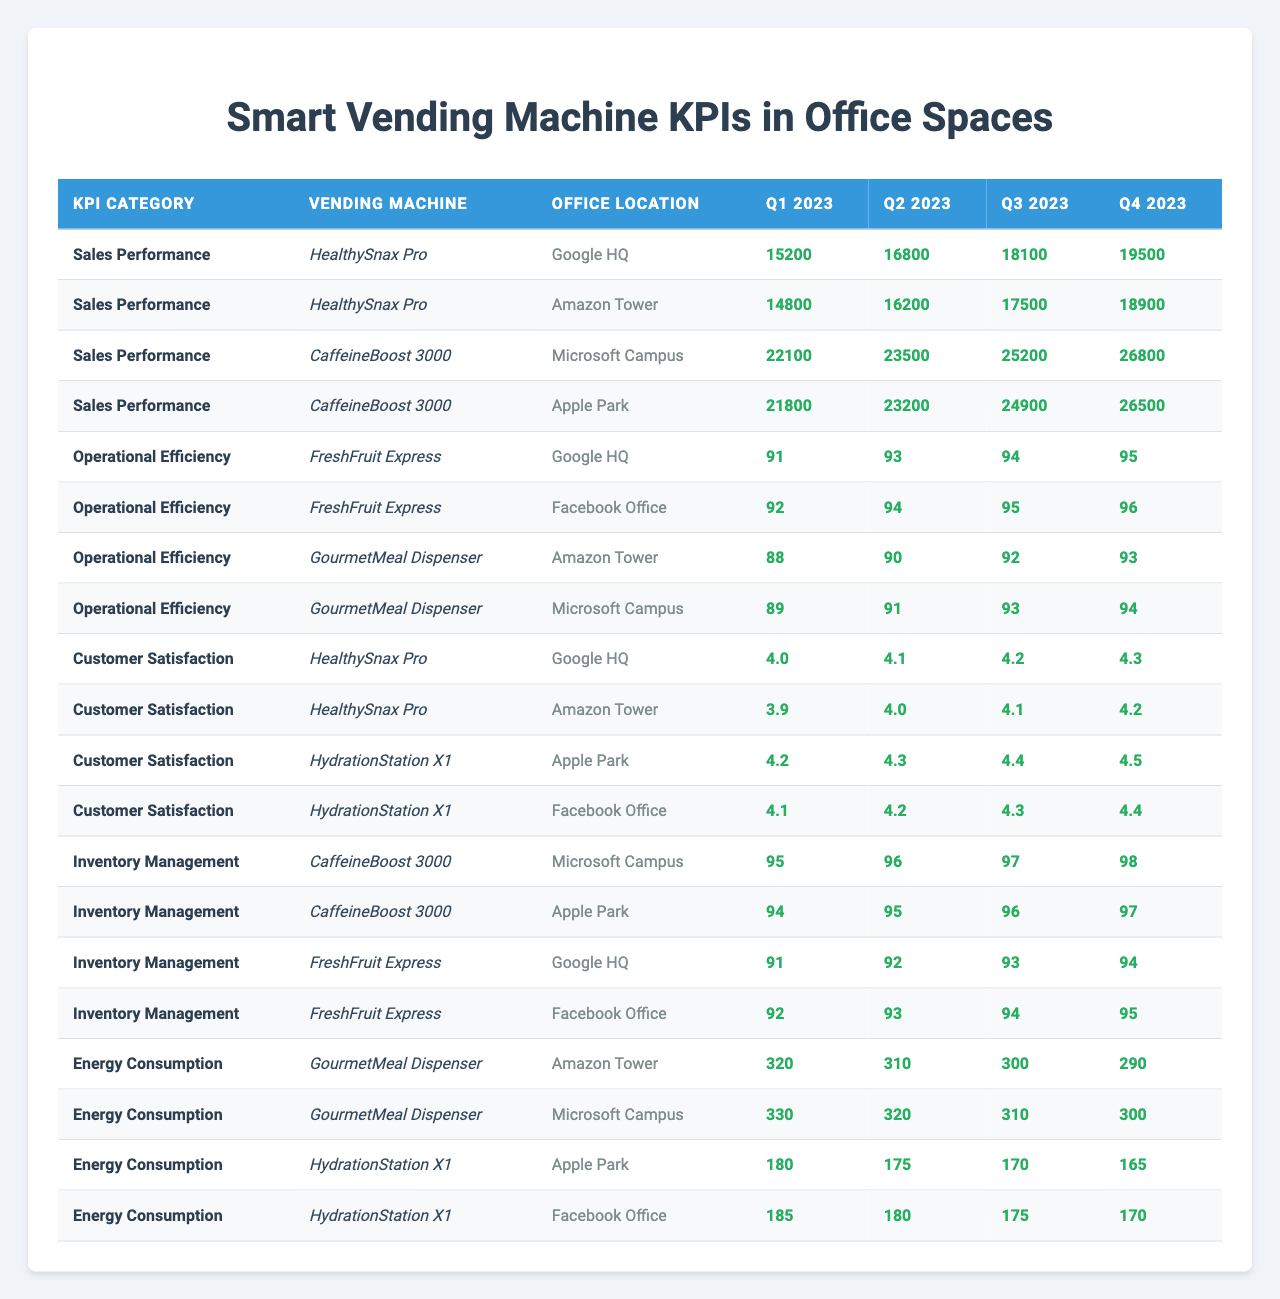What was the sales performance of HealthySnax Pro at Google HQ in Q2 2023? The table indicates a sales performance value of 16800 for HealthySnax Pro at Google HQ during Q2 2023.
Answer: 16800 Which vending machine had the highest customer satisfaction rating at Facebook Office in Q1 2023? The table shows that HealthySnax Pro had a rating of 4.1 and HydrationStation X1 had a rating of 4.1 in Q1 2023 at Facebook Office, hence both have the highest rating.
Answer: 4.1 What is the average operational efficiency rating for FreshFruit Express across its monitored office locations in Q3 2023? The efficiency ratings for FreshFruit Express in Q3 2023 are 95 at Facebook Office and 94 at Google HQ. The average is (95 + 94) / 2 = 94.5.
Answer: 94.5 Was the energy consumption of GourmetMeal Dispenser at Amazon Tower in Q4 2023 less than 300? The energy consumption for GourmetMeal Dispenser at Amazon Tower in Q4 2023 is 290, which is less than 300.
Answer: Yes How much did sales performance increase from Q1 2023 to Q4 2023 for CaffeineBoost 3000 at Microsoft Campus? The sales performance for CaffeineBoost 3000 at Microsoft Campus increased from 22100 (Q1 2023) to 26800 (Q4 2023), which is an increase of 26800 - 22100 = 4700.
Answer: 4700 Which machine had the lowest inventory management score at Apple Park in Q2 2023? The table shows that CaffeineBoost 3000 had a score of 95 while no other inventory management scores are listed for Apple Park, indicating it was the lowest recorded in the table.
Answer: 95 What was the highest sales figure recorded for HealthySnax Pro in 2023, and during which quarter and location did it occur? The highest sales figure for HealthySnax Pro is 19500, which occurred at Google HQ in Q4 2023.
Answer: 19500, Google HQ, Q4 2023 Calculate the total energy consumption for HydrationStation X1 across both monitored locations in all quarters. The total energy consumption for HydrationStation X1 is (180 + 175 + 170 + 165) at Apple Park and (185 + 180 + 175 + 170) at Facebook Office, summing up to 180 + 175 + 170 + 165 + 185 + 180 + 175 + 170 = 1300.
Answer: 1300 Was the sales performance at Amazon Tower for HealthySnax Pro greater than the same machine's sales at Google HQ in Q3 2023? HealthySnax Pro's sales at Amazon Tower in Q3 2023 is 17500, which is less than 18100 at Google HQ, confirming that it was not greater.
Answer: No What is the difference in customer satisfaction ratings between HealthySnax Pro and HydrationStation X1 at Q2 2023 in Amazon Tower? For Q2 2023, HealthySnax Pro has a rating of 4.0 and HydrationStation X1 has 4.3 in Amazon Tower. The difference is 4.3 - 4.0 = 0.3.
Answer: 0.3 